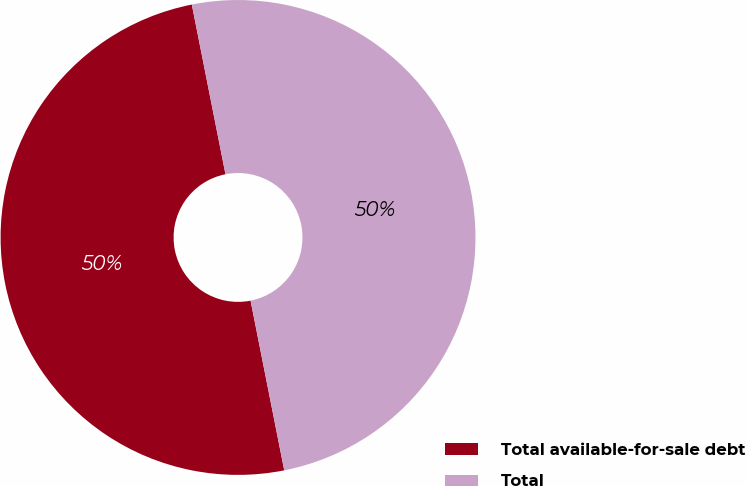Convert chart to OTSL. <chart><loc_0><loc_0><loc_500><loc_500><pie_chart><fcel>Total available-for-sale debt<fcel>Total<nl><fcel>50.0%<fcel>50.0%<nl></chart> 